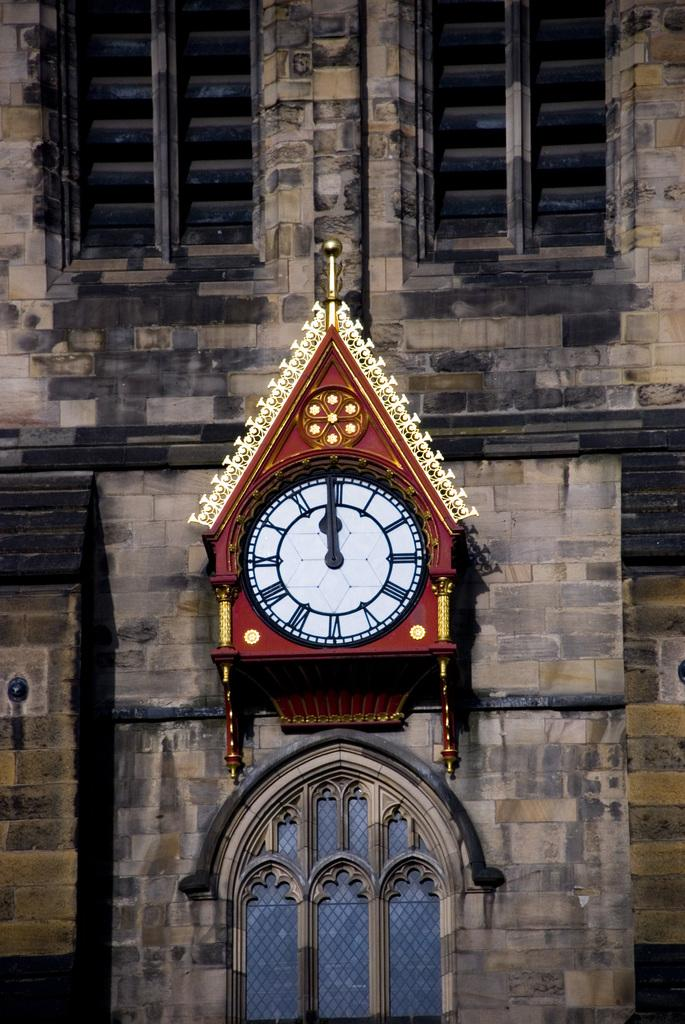<image>
Give a short and clear explanation of the subsequent image. a clock with roman numerals at midnight. 